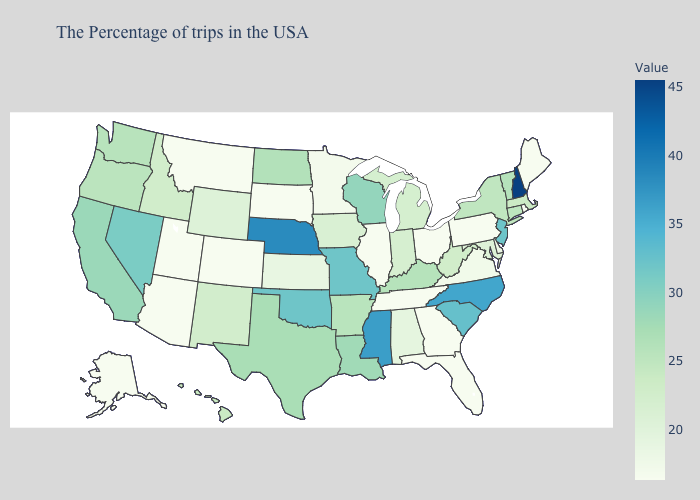Does Massachusetts have the lowest value in the Northeast?
Be succinct. No. Does New Hampshire have the highest value in the USA?
Answer briefly. Yes. Which states have the highest value in the USA?
Keep it brief. New Hampshire. Which states have the highest value in the USA?
Short answer required. New Hampshire. Does West Virginia have the highest value in the South?
Quick response, please. No. Does Rhode Island have the lowest value in the USA?
Be succinct. Yes. Which states have the lowest value in the West?
Quick response, please. Colorado, Utah, Montana, Arizona, Alaska. 